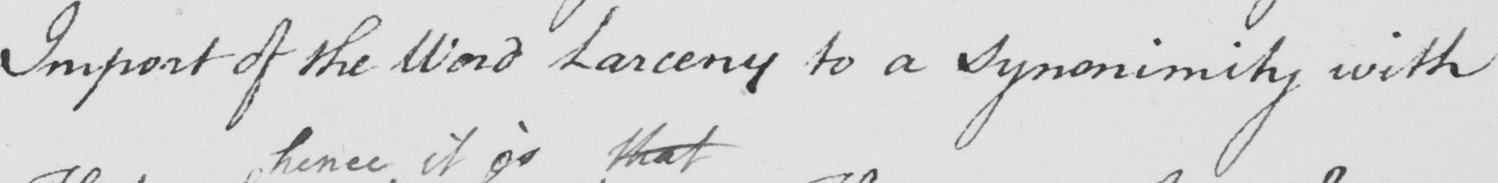What does this handwritten line say? Import of the Word Larceny to a Synonimity with 